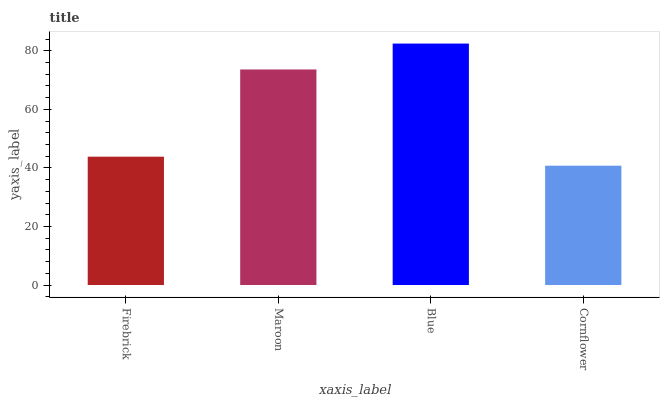Is Cornflower the minimum?
Answer yes or no. Yes. Is Blue the maximum?
Answer yes or no. Yes. Is Maroon the minimum?
Answer yes or no. No. Is Maroon the maximum?
Answer yes or no. No. Is Maroon greater than Firebrick?
Answer yes or no. Yes. Is Firebrick less than Maroon?
Answer yes or no. Yes. Is Firebrick greater than Maroon?
Answer yes or no. No. Is Maroon less than Firebrick?
Answer yes or no. No. Is Maroon the high median?
Answer yes or no. Yes. Is Firebrick the low median?
Answer yes or no. Yes. Is Blue the high median?
Answer yes or no. No. Is Blue the low median?
Answer yes or no. No. 